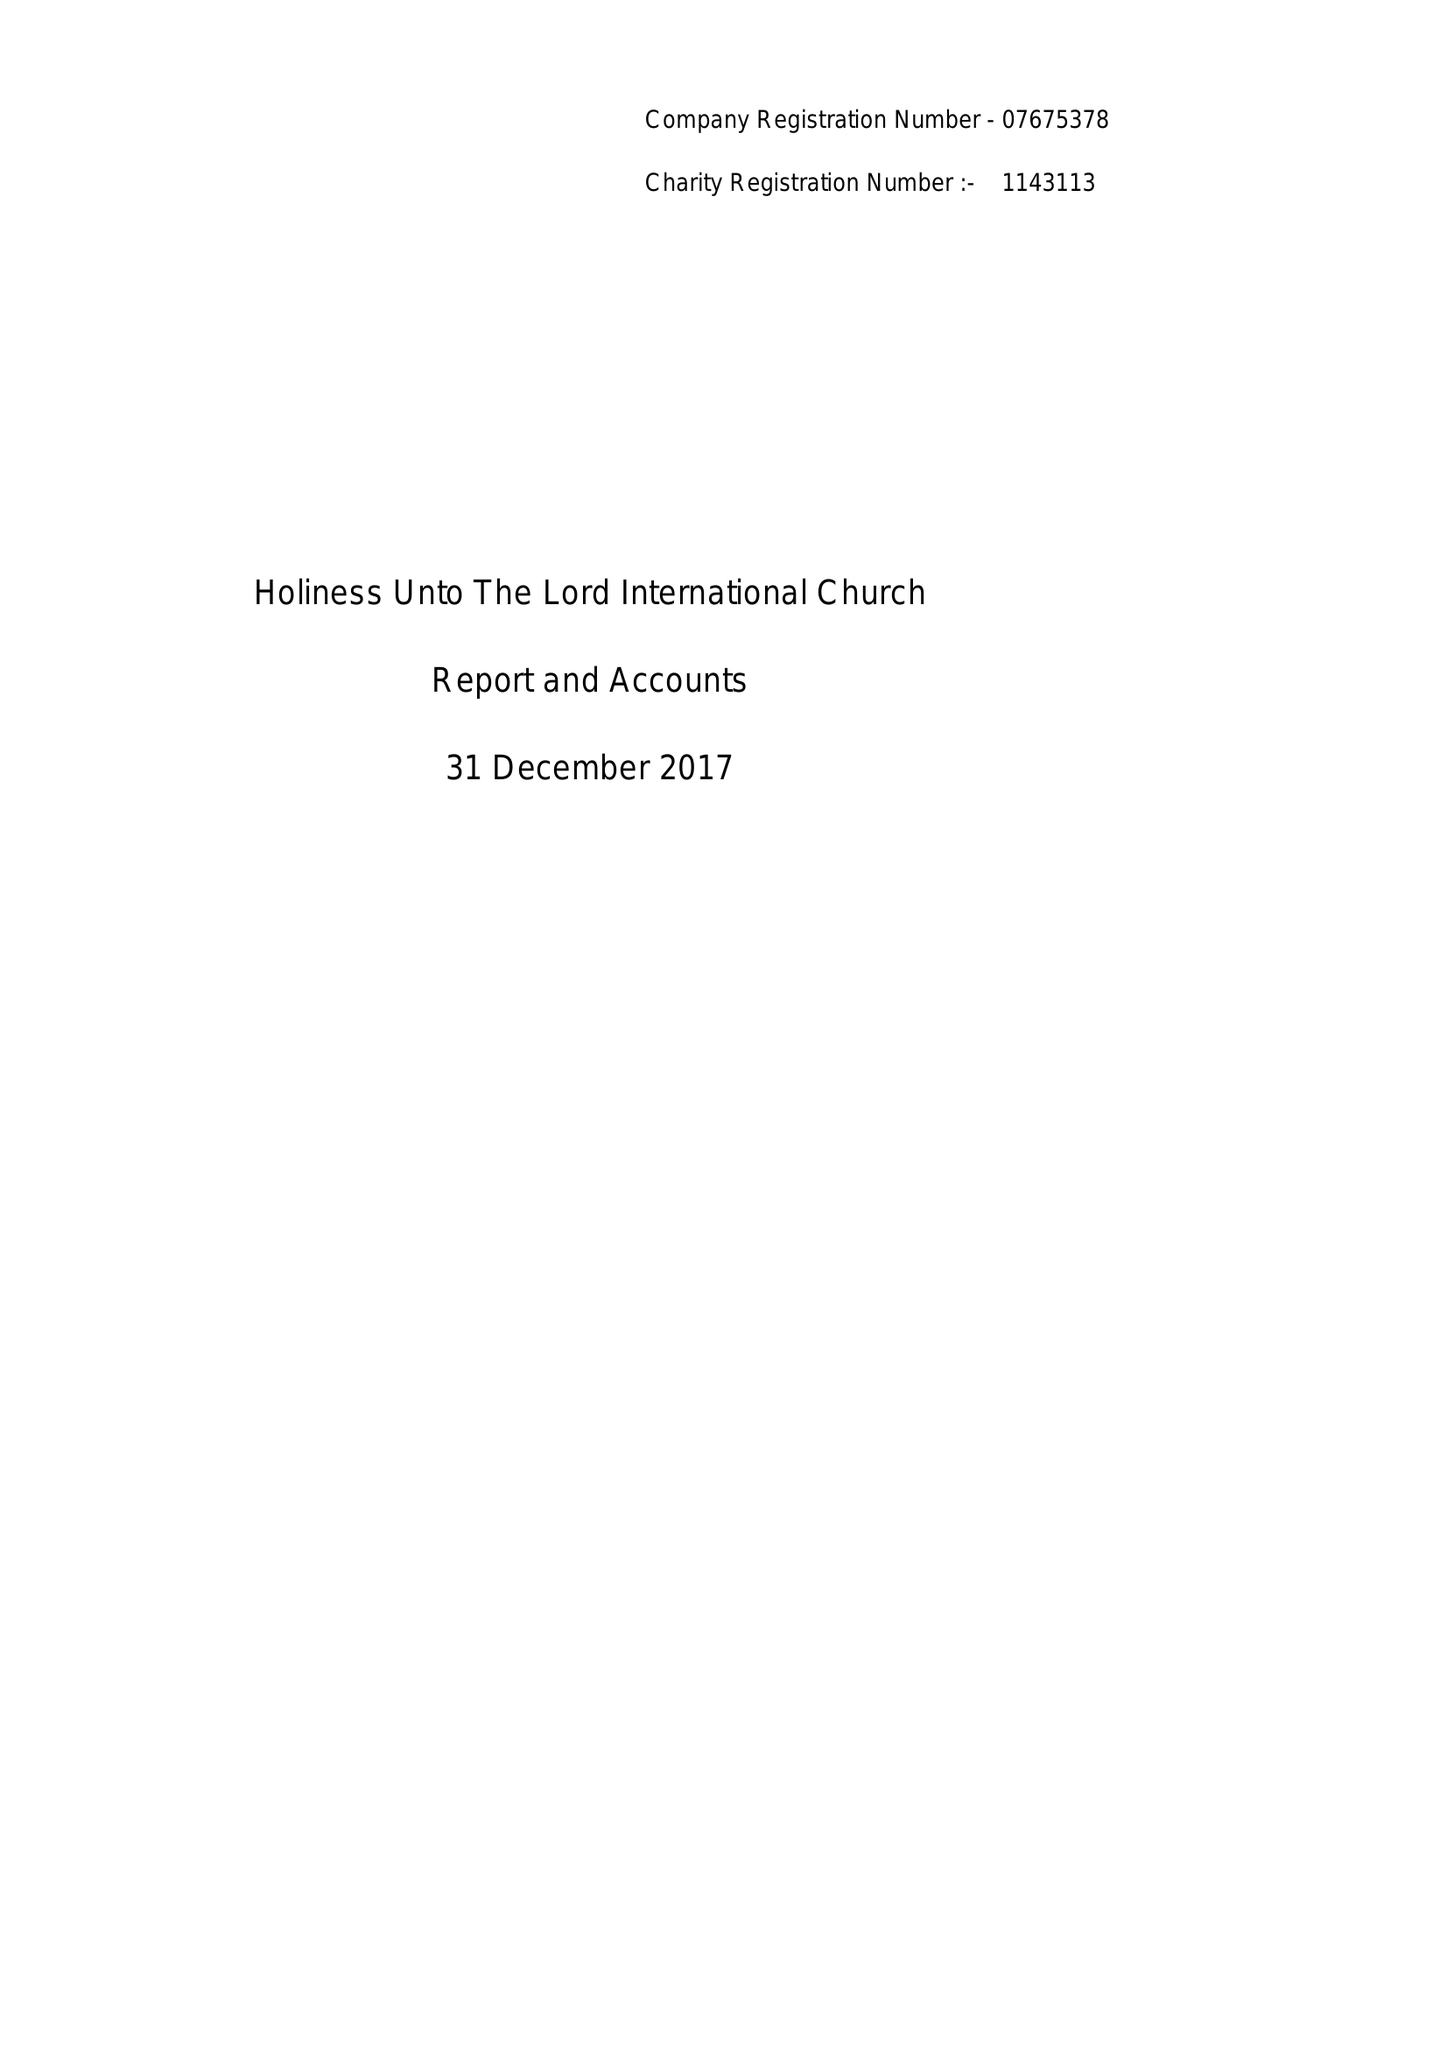What is the value for the address__postcode?
Answer the question using a single word or phrase. W3 7QS 